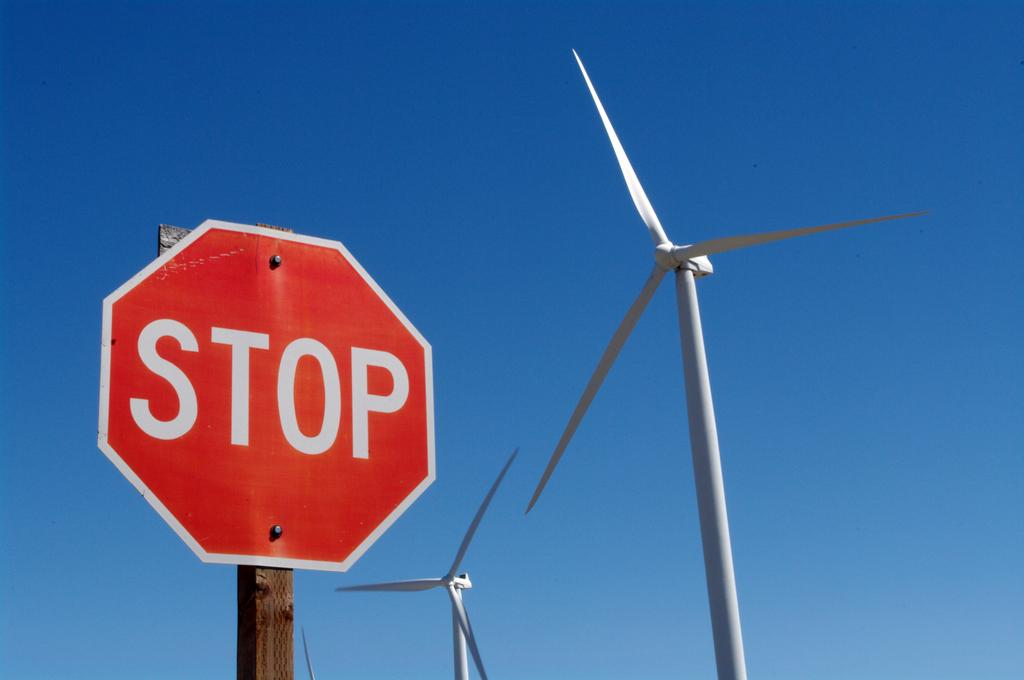<image>
Offer a succinct explanation of the picture presented. Red stop sign outside in front of a blue sky. 